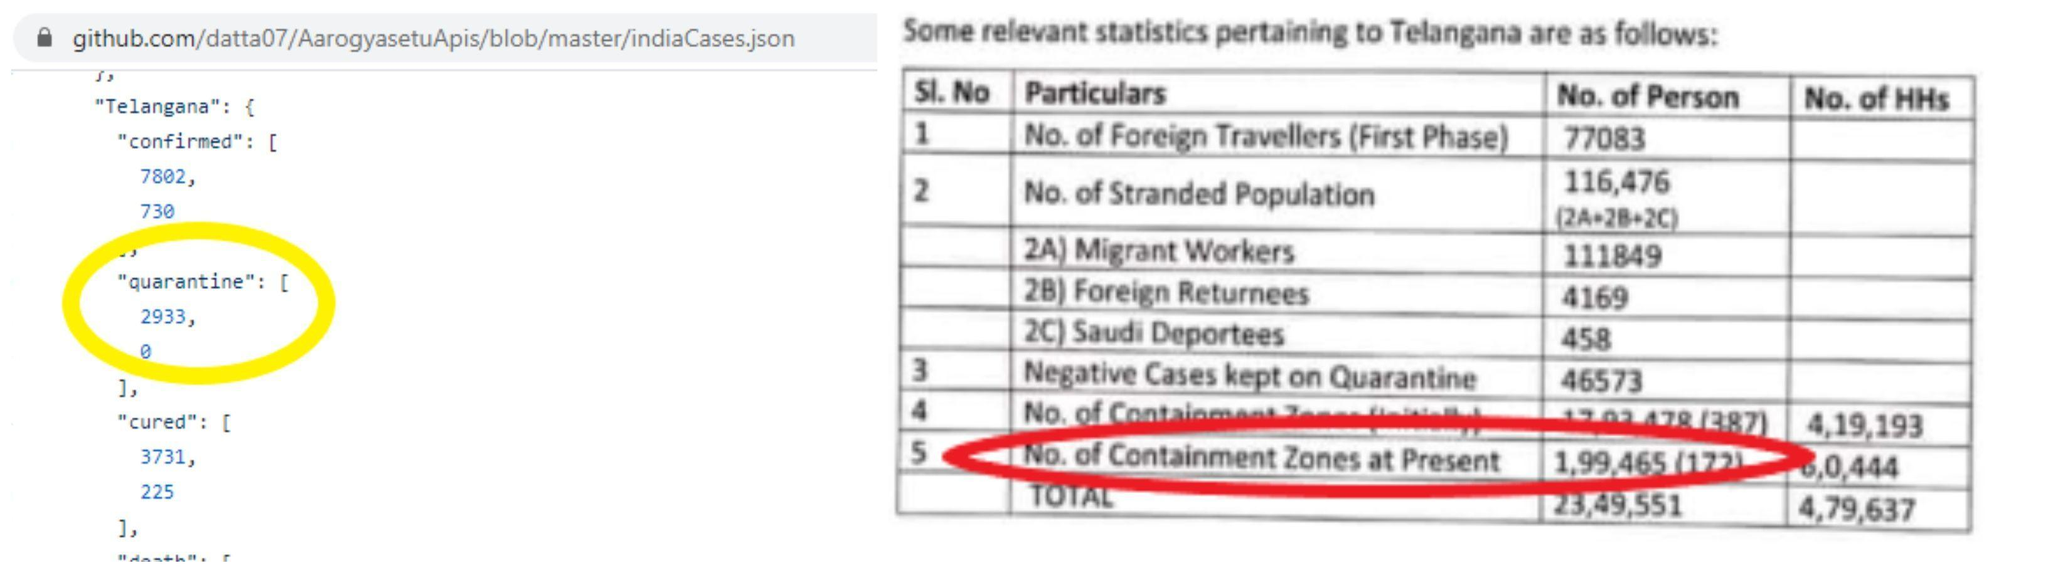Among the stranded population, whose number is the highest?
Answer the question with a short phrase. Migrant Workers 